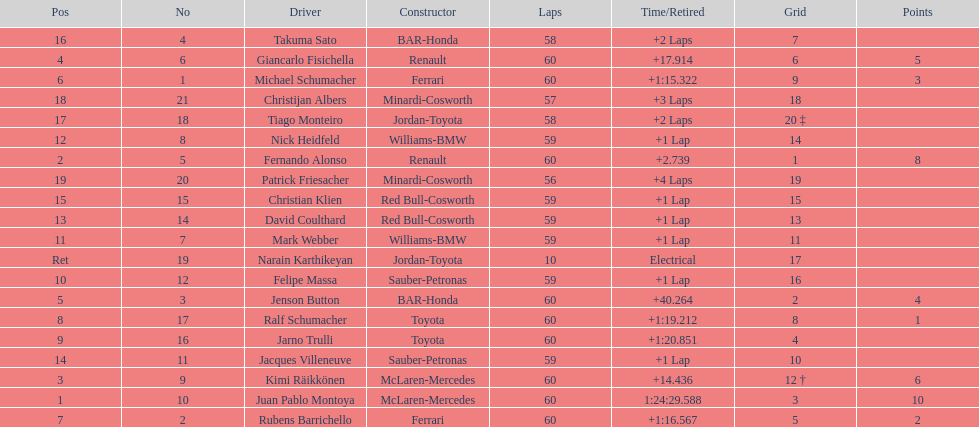Following the 8th place, how many points are awarded to a driver? 0. 